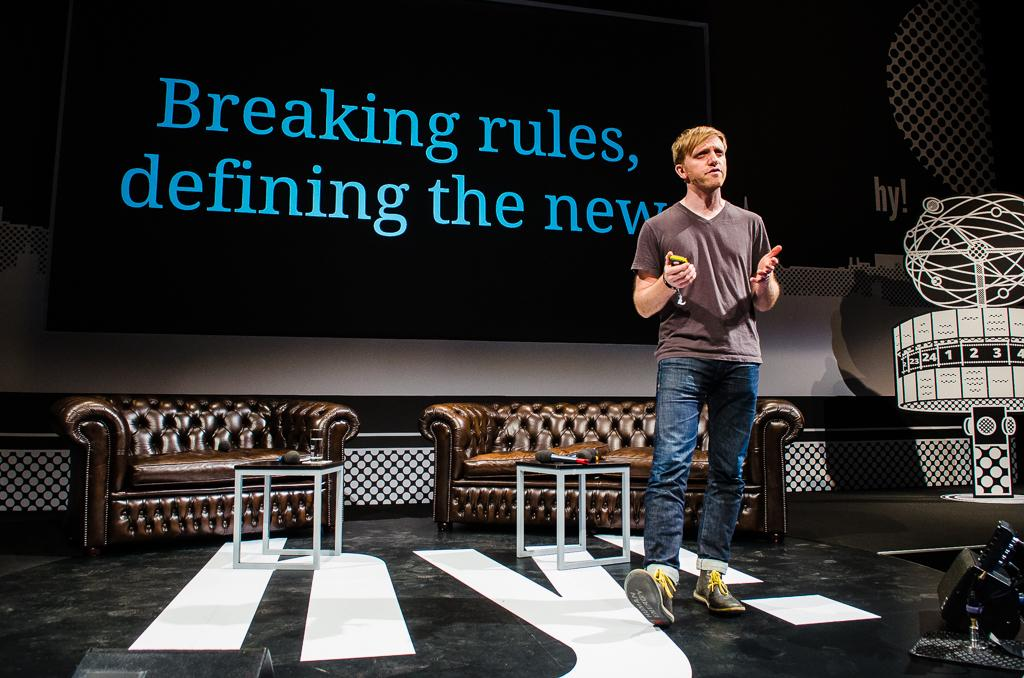What is the main subject of the image? There is a man standing in the center of the image. What can be seen in the background of the image? There are sofas and a screen with text written on it in the background of the image. What hobbies does the man have, as depicted in the image? The image does not provide any information about the man's hobbies. What type of flesh can be seen on the man's body in the image? The image does not show any flesh on the man's body; he is fully clothed. 